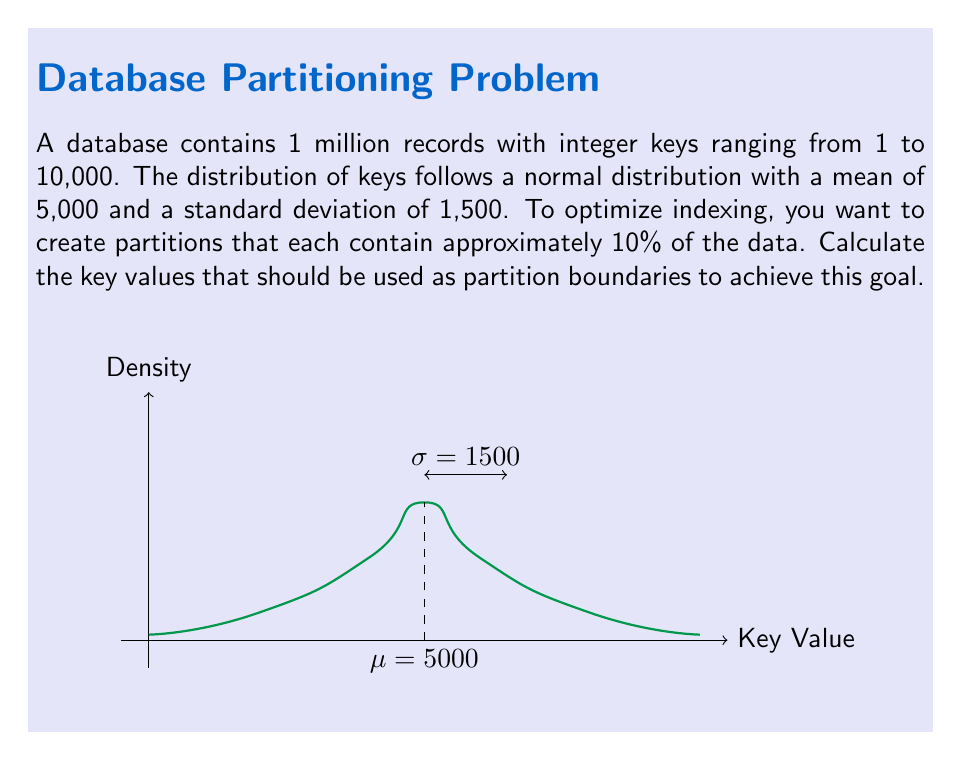What is the answer to this math problem? To solve this problem, we need to find the key values that divide the normal distribution into 10 equal parts. This involves calculating the z-scores for the 10th, 20th, ..., 90th percentiles and then converting these z-scores back to key values.

Step 1: Determine the z-scores for the required percentiles.
We need the z-scores for the 10th, 20th, ..., 90th percentiles. These can be found using the inverse of the standard normal cumulative distribution function (often denoted as $\Phi^{-1}$).

10th percentile: $z_{0.1} \approx -1.28$
20th percentile: $z_{0.2} \approx -0.84$
30th percentile: $z_{0.3} \approx -0.52$
40th percentile: $z_{0.4} \approx -0.25$
50th percentile: $z_{0.5} = 0$
60th percentile: $z_{0.6} \approx 0.25$
70th percentile: $z_{0.7} \approx 0.52$
80th percentile: $z_{0.8} \approx 0.84$
90th percentile: $z_{0.9} \approx 1.28$

Step 2: Convert z-scores to key values.
For a normal distribution, we can convert a z-score to a value using the formula:

$$ x = \mu + z\sigma $$

Where $x$ is the key value, $\mu$ is the mean (5000), $\sigma$ is the standard deviation (1500), and $z$ is the z-score.

Calculating for each percentile:

10th: $x_{0.1} = 5000 + (-1.28 * 1500) \approx 3080$
20th: $x_{0.2} = 5000 + (-0.84 * 1500) \approx 3740$
30th: $x_{0.3} = 5000 + (-0.52 * 1500) \approx 4220$
40th: $x_{0.4} = 5000 + (-0.25 * 1500) \approx 4625$
50th: $x_{0.5} = 5000 + (0 * 1500) = 5000$
60th: $x_{0.6} = 5000 + (0.25 * 1500) \approx 5375$
70th: $x_{0.7} = 5000 + (0.52 * 1500) \approx 5780$
80th: $x_{0.8} = 5000 + (0.84 * 1500) \approx 6260$
90th: $x_{0.9} = 5000 + (1.28 * 1500) \approx 6920$

These key values represent the boundaries for partitions that will each contain approximately 10% of the data.
Answer: 3080, 3740, 4220, 4625, 5000, 5375, 5780, 6260, 6920 